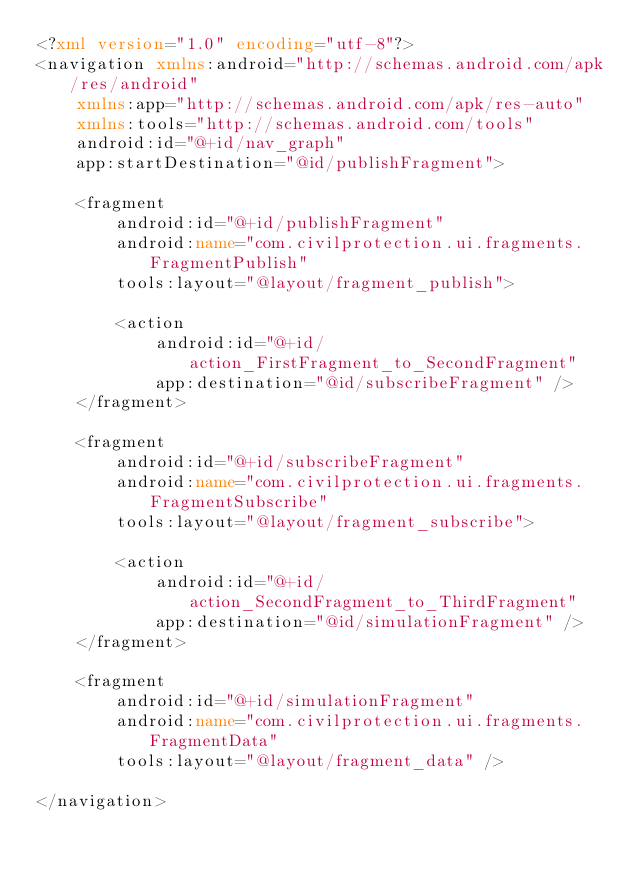<code> <loc_0><loc_0><loc_500><loc_500><_XML_><?xml version="1.0" encoding="utf-8"?>
<navigation xmlns:android="http://schemas.android.com/apk/res/android"
    xmlns:app="http://schemas.android.com/apk/res-auto"
    xmlns:tools="http://schemas.android.com/tools"
    android:id="@+id/nav_graph"
    app:startDestination="@id/publishFragment">

    <fragment
        android:id="@+id/publishFragment"
        android:name="com.civilprotection.ui.fragments.FragmentPublish"
        tools:layout="@layout/fragment_publish">

        <action
            android:id="@+id/action_FirstFragment_to_SecondFragment"
            app:destination="@id/subscribeFragment" />
    </fragment>

    <fragment
        android:id="@+id/subscribeFragment"
        android:name="com.civilprotection.ui.fragments.FragmentSubscribe"
        tools:layout="@layout/fragment_subscribe">

        <action
            android:id="@+id/action_SecondFragment_to_ThirdFragment"
            app:destination="@id/simulationFragment" />
    </fragment>

    <fragment
        android:id="@+id/simulationFragment"
        android:name="com.civilprotection.ui.fragments.FragmentData"
        tools:layout="@layout/fragment_data" />

</navigation></code> 